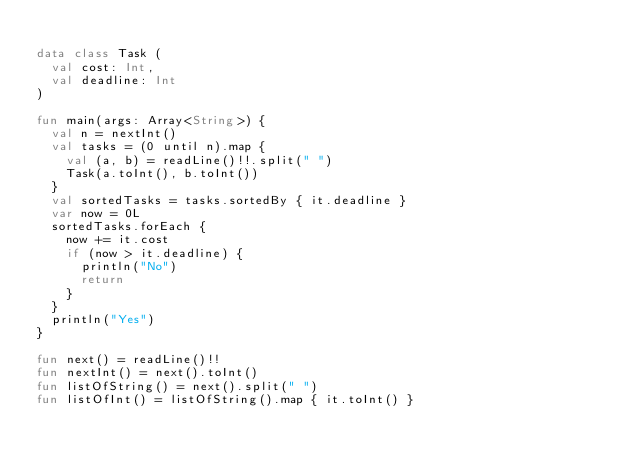<code> <loc_0><loc_0><loc_500><loc_500><_Kotlin_>
data class Task (
  val cost: Int,
  val deadline: Int
)

fun main(args: Array<String>) {
  val n = nextInt()
  val tasks = (0 until n).map {
    val (a, b) = readLine()!!.split(" ")
    Task(a.toInt(), b.toInt())
  }
  val sortedTasks = tasks.sortedBy { it.deadline }
  var now = 0L
  sortedTasks.forEach {
    now += it.cost
    if (now > it.deadline) {
      println("No")
      return
    }
  }
  println("Yes")
}

fun next() = readLine()!!
fun nextInt() = next().toInt()
fun listOfString() = next().split(" ")
fun listOfInt() = listOfString().map { it.toInt() }</code> 